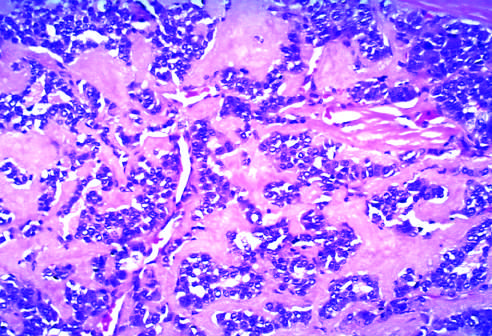what is derived from calcitonin molecules secreted by the neoplastic cells?
Answer the question using a single word or phrase. Amyloid 